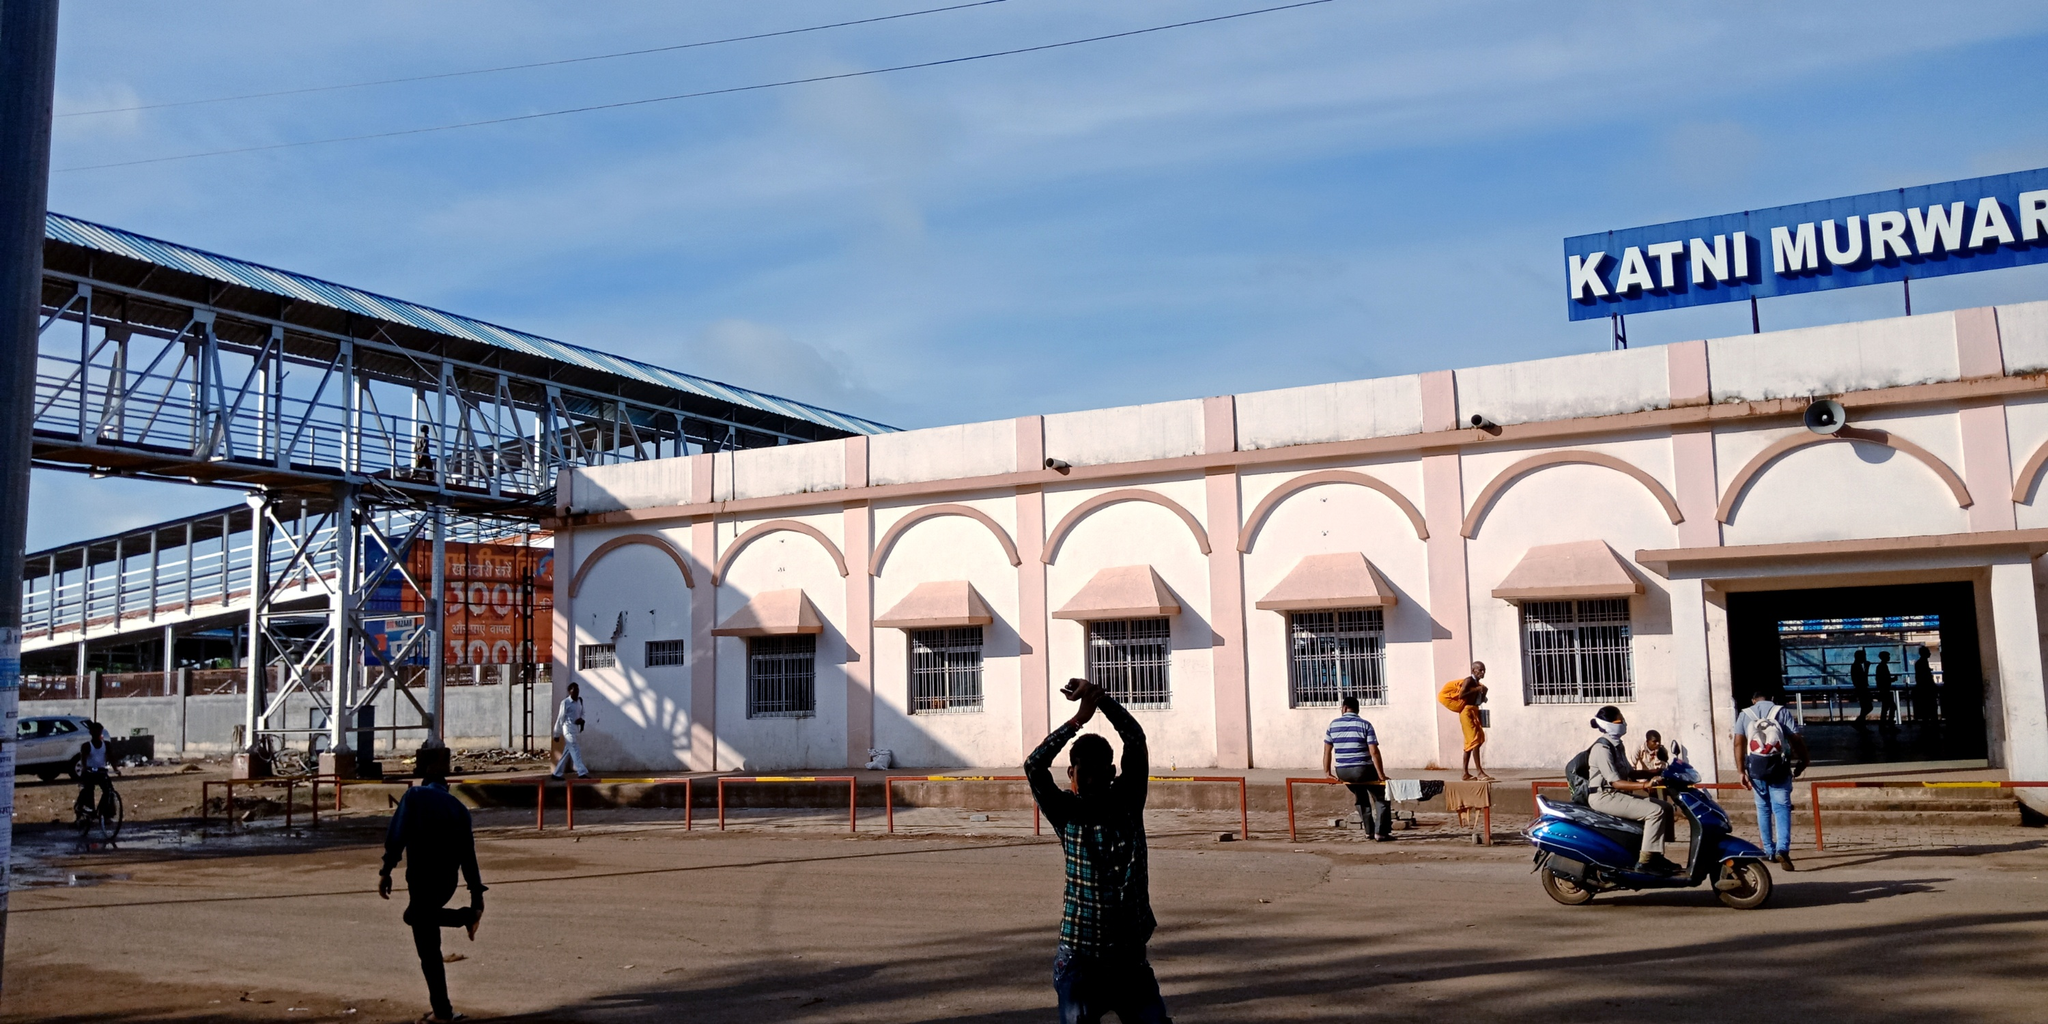What does the architecture of the station tell us about its history or significance? The architecture of the Katni Murwara station, with its pink arches and white walls accented with blue, reflects a blend of traditional and practical design elements. The robust arches and thick walls are indicative of architectural styles aiming for durability and a welcoming atmosphere. The prominence and clarity of the station's name in large blue letters highlight its importance as a key transit point in the region. Additionally, the arches and colors may speak to regional aesthetic preferences, embedding the station in its cultural and geographical context. 